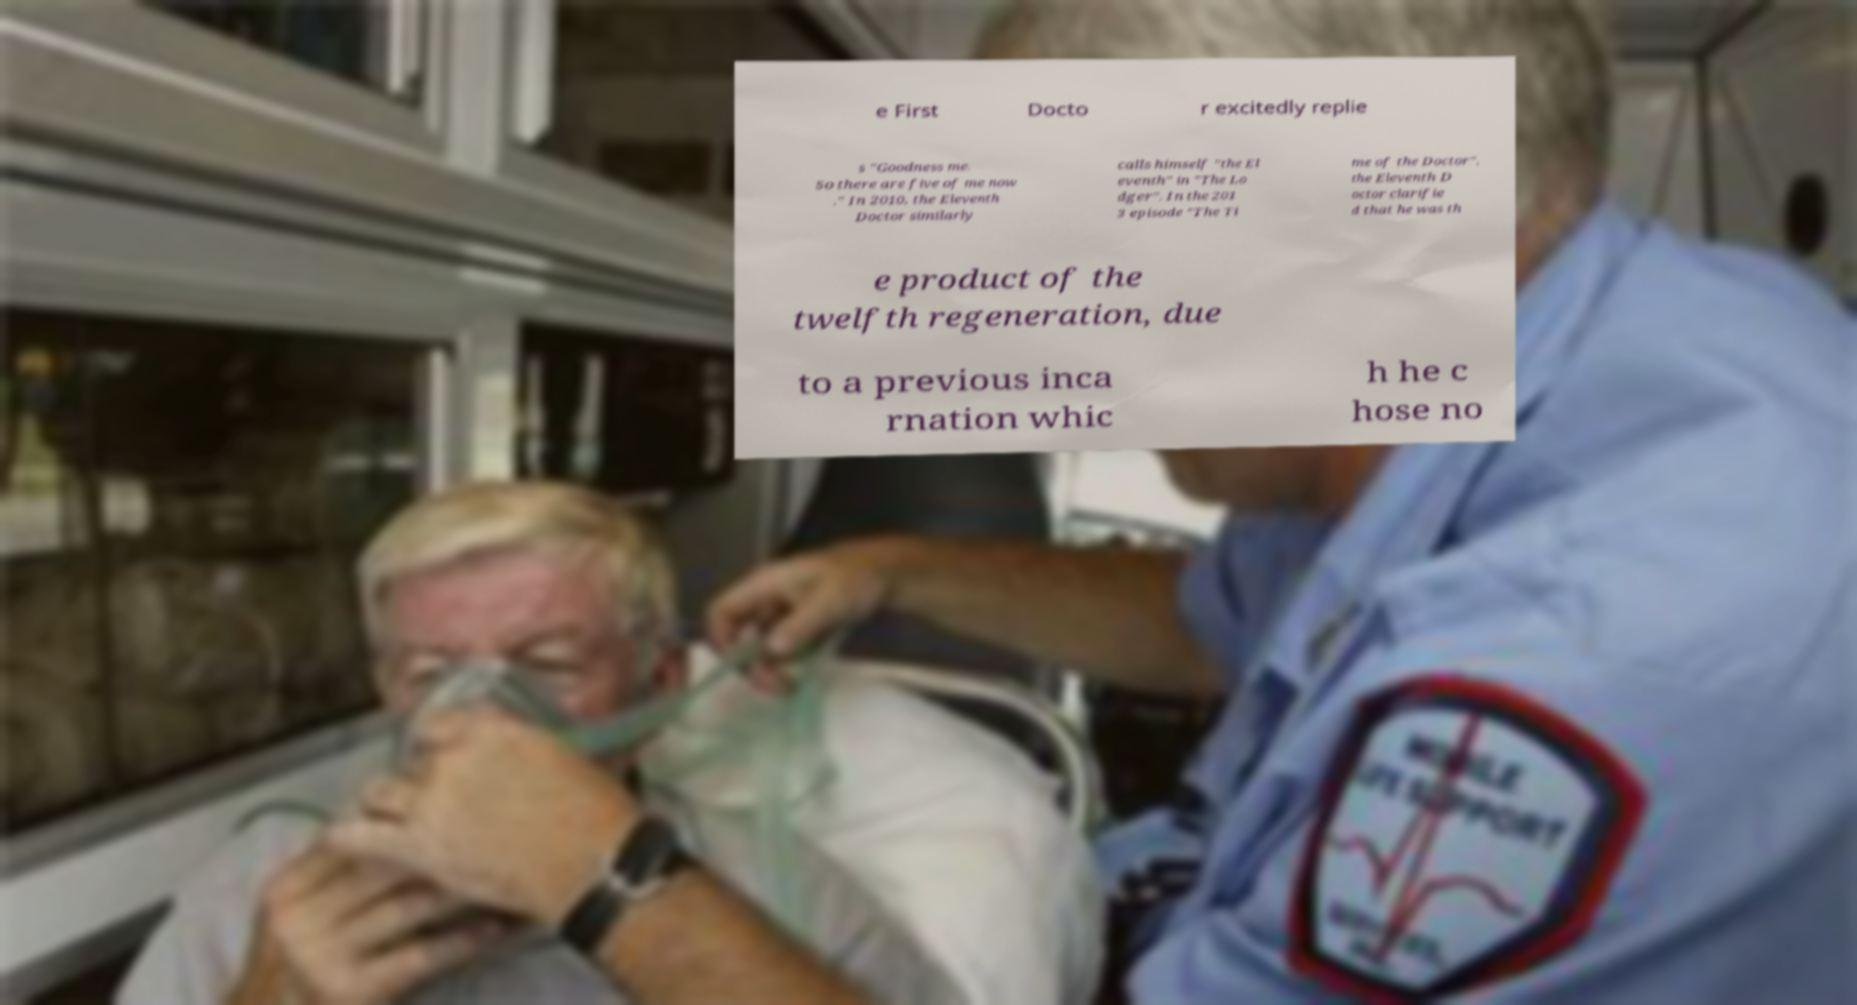Can you read and provide the text displayed in the image?This photo seems to have some interesting text. Can you extract and type it out for me? e First Docto r excitedly replie s "Goodness me. So there are five of me now ." In 2010, the Eleventh Doctor similarly calls himself "the El eventh" in "The Lo dger". In the 201 3 episode "The Ti me of the Doctor", the Eleventh D octor clarifie d that he was th e product of the twelfth regeneration, due to a previous inca rnation whic h he c hose no 